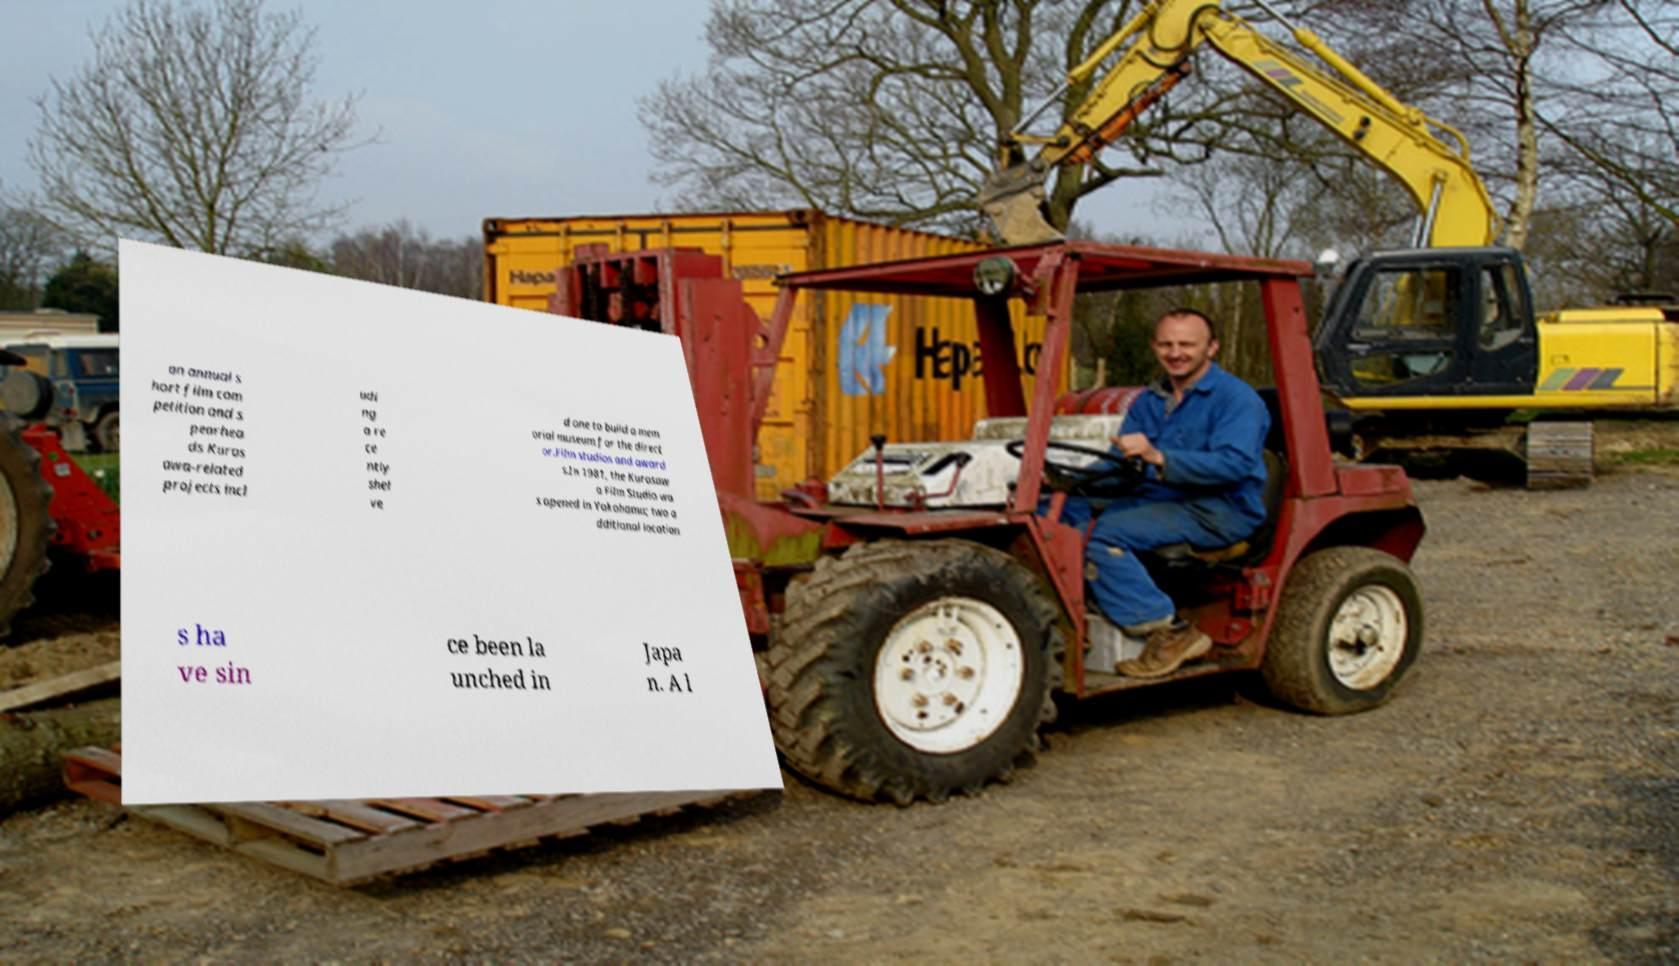I need the written content from this picture converted into text. Can you do that? an annual s hort film com petition and s pearhea ds Kuros awa-related projects incl udi ng a re ce ntly shel ve d one to build a mem orial museum for the direct or.Film studios and award s.In 1981, the Kurosaw a Film Studio wa s opened in Yokohama; two a dditional location s ha ve sin ce been la unched in Japa n. A l 